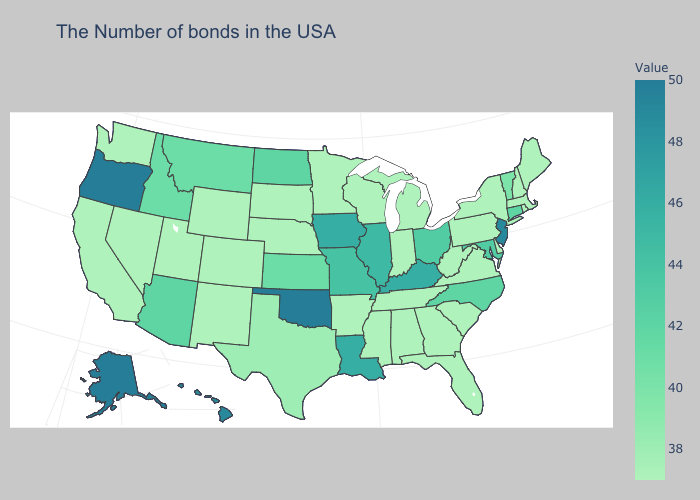Is the legend a continuous bar?
Keep it brief. Yes. Which states have the highest value in the USA?
Be succinct. Oklahoma, Oregon, Alaska. Does Arizona have the highest value in the USA?
Concise answer only. No. Does Wyoming have a lower value than Kentucky?
Short answer required. Yes. Does Rhode Island have the lowest value in the Northeast?
Be succinct. Yes. 